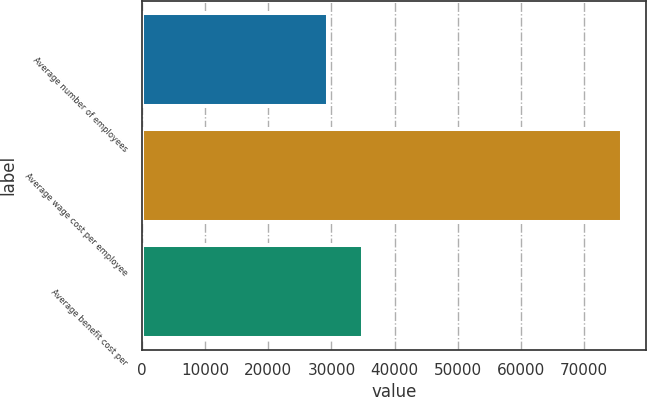Convert chart to OTSL. <chart><loc_0><loc_0><loc_500><loc_500><bar_chart><fcel>Average number of employees<fcel>Average wage cost per employee<fcel>Average benefit cost per<nl><fcel>29482<fcel>76000<fcel>35000<nl></chart> 